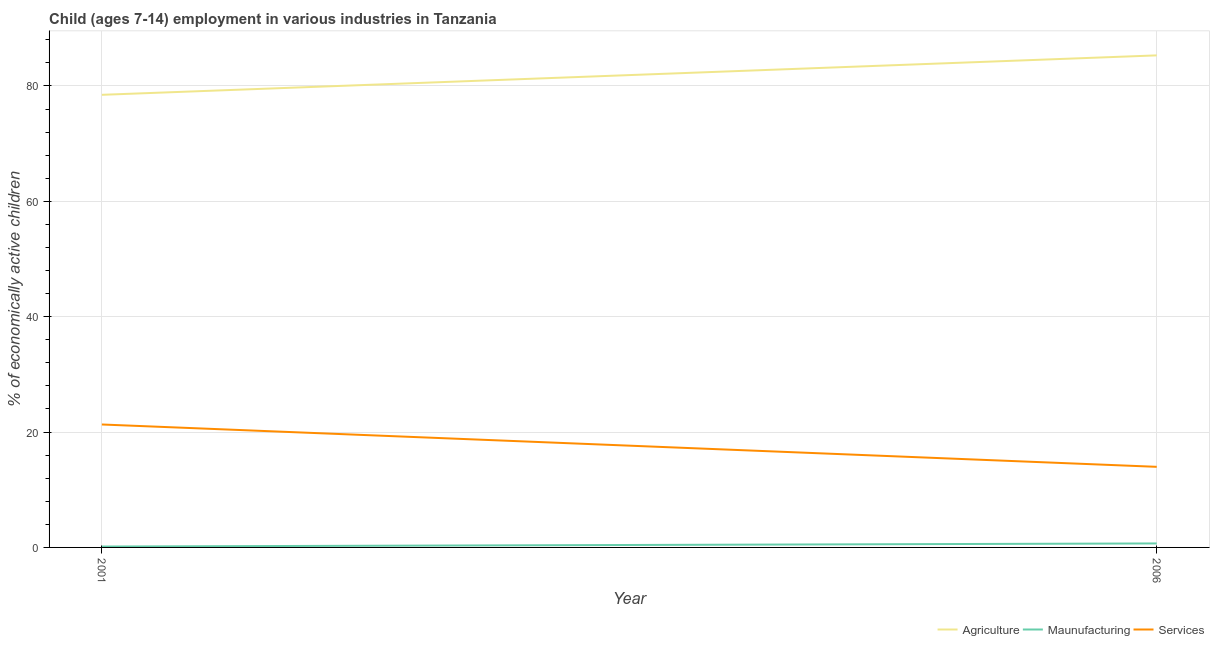How many different coloured lines are there?
Offer a very short reply. 3. Is the number of lines equal to the number of legend labels?
Your answer should be very brief. Yes. What is the percentage of economically active children in agriculture in 2006?
Keep it short and to the point. 85.3. Across all years, what is the maximum percentage of economically active children in agriculture?
Ensure brevity in your answer.  85.3. Across all years, what is the minimum percentage of economically active children in manufacturing?
Your answer should be compact. 0.15. In which year was the percentage of economically active children in services maximum?
Give a very brief answer. 2001. What is the total percentage of economically active children in agriculture in the graph?
Your answer should be very brief. 163.76. What is the difference between the percentage of economically active children in services in 2001 and that in 2006?
Give a very brief answer. 7.34. What is the difference between the percentage of economically active children in services in 2006 and the percentage of economically active children in agriculture in 2001?
Make the answer very short. -64.49. What is the average percentage of economically active children in agriculture per year?
Give a very brief answer. 81.88. In the year 2006, what is the difference between the percentage of economically active children in manufacturing and percentage of economically active children in services?
Keep it short and to the point. -13.28. In how many years, is the percentage of economically active children in services greater than 60 %?
Make the answer very short. 0. What is the ratio of the percentage of economically active children in services in 2001 to that in 2006?
Your answer should be compact. 1.53. In how many years, is the percentage of economically active children in agriculture greater than the average percentage of economically active children in agriculture taken over all years?
Offer a terse response. 1. Does the percentage of economically active children in manufacturing monotonically increase over the years?
Offer a very short reply. Yes. Is the percentage of economically active children in agriculture strictly greater than the percentage of economically active children in services over the years?
Offer a terse response. Yes. Is the percentage of economically active children in manufacturing strictly less than the percentage of economically active children in services over the years?
Your answer should be compact. Yes. How many years are there in the graph?
Make the answer very short. 2. What is the difference between two consecutive major ticks on the Y-axis?
Offer a very short reply. 20. Are the values on the major ticks of Y-axis written in scientific E-notation?
Your answer should be compact. No. Does the graph contain grids?
Your answer should be very brief. Yes. Where does the legend appear in the graph?
Give a very brief answer. Bottom right. What is the title of the graph?
Ensure brevity in your answer.  Child (ages 7-14) employment in various industries in Tanzania. Does "Agricultural raw materials" appear as one of the legend labels in the graph?
Your answer should be very brief. No. What is the label or title of the X-axis?
Offer a very short reply. Year. What is the label or title of the Y-axis?
Ensure brevity in your answer.  % of economically active children. What is the % of economically active children of Agriculture in 2001?
Offer a very short reply. 78.46. What is the % of economically active children of Maunufacturing in 2001?
Give a very brief answer. 0.15. What is the % of economically active children of Services in 2001?
Make the answer very short. 21.31. What is the % of economically active children of Agriculture in 2006?
Your answer should be very brief. 85.3. What is the % of economically active children in Maunufacturing in 2006?
Provide a short and direct response. 0.69. What is the % of economically active children of Services in 2006?
Provide a succinct answer. 13.97. Across all years, what is the maximum % of economically active children of Agriculture?
Offer a terse response. 85.3. Across all years, what is the maximum % of economically active children of Maunufacturing?
Keep it short and to the point. 0.69. Across all years, what is the maximum % of economically active children in Services?
Offer a terse response. 21.31. Across all years, what is the minimum % of economically active children in Agriculture?
Ensure brevity in your answer.  78.46. Across all years, what is the minimum % of economically active children in Maunufacturing?
Your response must be concise. 0.15. Across all years, what is the minimum % of economically active children of Services?
Provide a short and direct response. 13.97. What is the total % of economically active children in Agriculture in the graph?
Give a very brief answer. 163.76. What is the total % of economically active children of Maunufacturing in the graph?
Provide a short and direct response. 0.84. What is the total % of economically active children in Services in the graph?
Ensure brevity in your answer.  35.28. What is the difference between the % of economically active children in Agriculture in 2001 and that in 2006?
Your answer should be compact. -6.84. What is the difference between the % of economically active children of Maunufacturing in 2001 and that in 2006?
Your answer should be compact. -0.54. What is the difference between the % of economically active children of Services in 2001 and that in 2006?
Offer a terse response. 7.34. What is the difference between the % of economically active children in Agriculture in 2001 and the % of economically active children in Maunufacturing in 2006?
Keep it short and to the point. 77.77. What is the difference between the % of economically active children in Agriculture in 2001 and the % of economically active children in Services in 2006?
Offer a very short reply. 64.49. What is the difference between the % of economically active children of Maunufacturing in 2001 and the % of economically active children of Services in 2006?
Your answer should be very brief. -13.82. What is the average % of economically active children in Agriculture per year?
Provide a succinct answer. 81.88. What is the average % of economically active children in Maunufacturing per year?
Make the answer very short. 0.42. What is the average % of economically active children in Services per year?
Provide a short and direct response. 17.64. In the year 2001, what is the difference between the % of economically active children in Agriculture and % of economically active children in Maunufacturing?
Make the answer very short. 78.31. In the year 2001, what is the difference between the % of economically active children in Agriculture and % of economically active children in Services?
Your response must be concise. 57.15. In the year 2001, what is the difference between the % of economically active children in Maunufacturing and % of economically active children in Services?
Offer a very short reply. -21.16. In the year 2006, what is the difference between the % of economically active children of Agriculture and % of economically active children of Maunufacturing?
Provide a succinct answer. 84.61. In the year 2006, what is the difference between the % of economically active children of Agriculture and % of economically active children of Services?
Ensure brevity in your answer.  71.33. In the year 2006, what is the difference between the % of economically active children of Maunufacturing and % of economically active children of Services?
Your answer should be compact. -13.28. What is the ratio of the % of economically active children of Agriculture in 2001 to that in 2006?
Your answer should be very brief. 0.92. What is the ratio of the % of economically active children of Maunufacturing in 2001 to that in 2006?
Your answer should be very brief. 0.22. What is the ratio of the % of economically active children of Services in 2001 to that in 2006?
Provide a short and direct response. 1.53. What is the difference between the highest and the second highest % of economically active children in Agriculture?
Make the answer very short. 6.84. What is the difference between the highest and the second highest % of economically active children of Maunufacturing?
Offer a terse response. 0.54. What is the difference between the highest and the second highest % of economically active children of Services?
Give a very brief answer. 7.34. What is the difference between the highest and the lowest % of economically active children of Agriculture?
Keep it short and to the point. 6.84. What is the difference between the highest and the lowest % of economically active children in Maunufacturing?
Make the answer very short. 0.54. What is the difference between the highest and the lowest % of economically active children of Services?
Give a very brief answer. 7.34. 